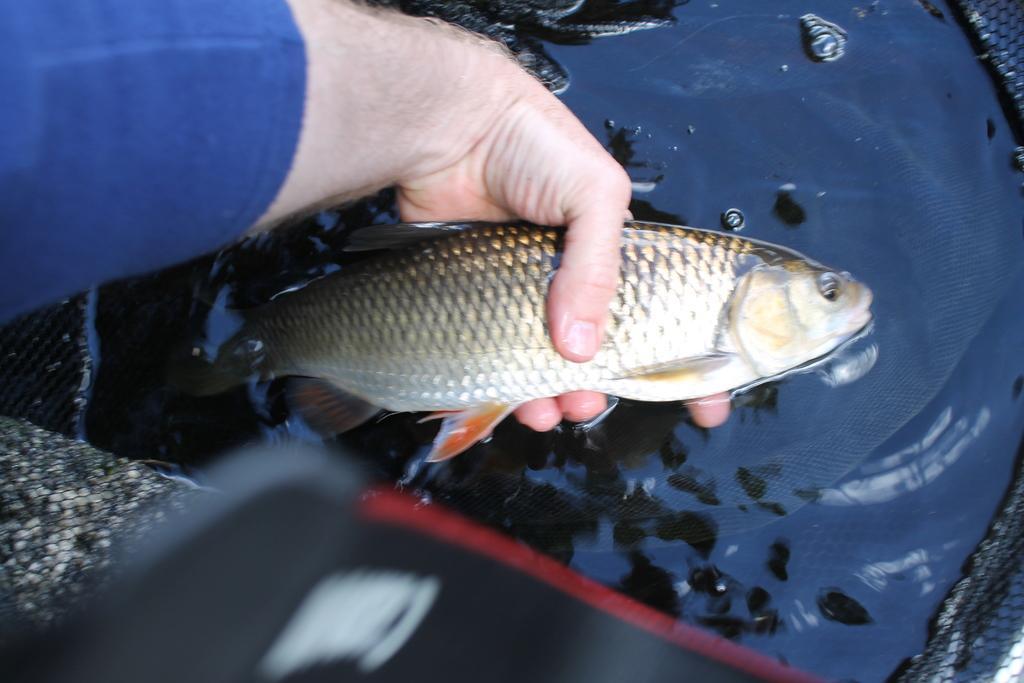Please provide a concise description of this image. In this image we can see some person's hand and that person is holding the fish. We can also see the water and also the net. 